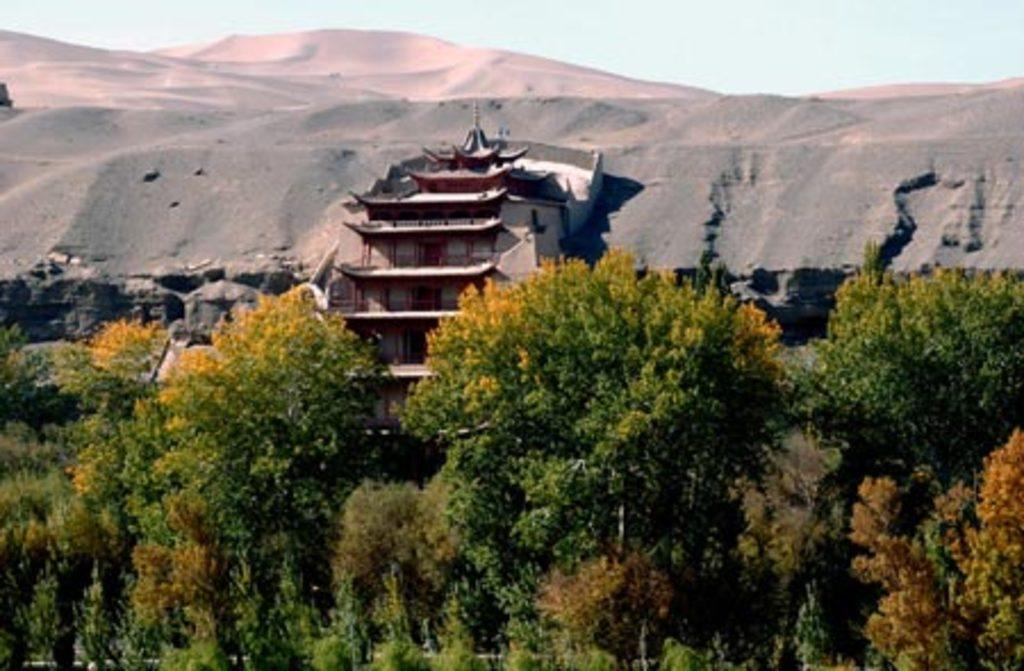What type of vegetation can be seen in the image? There are trees in the image. What type of structure is visible in the background of the image? There is a building in the background of the image. What natural landmarks can be seen in the background of the image? There are mountains in the background of the image. What is the condition of the sky in the image? The sky is clear and visible in the background of the image. What is the opinion of the trees about the mountains in the image? Trees do not have opinions, as they are inanimate objects. 